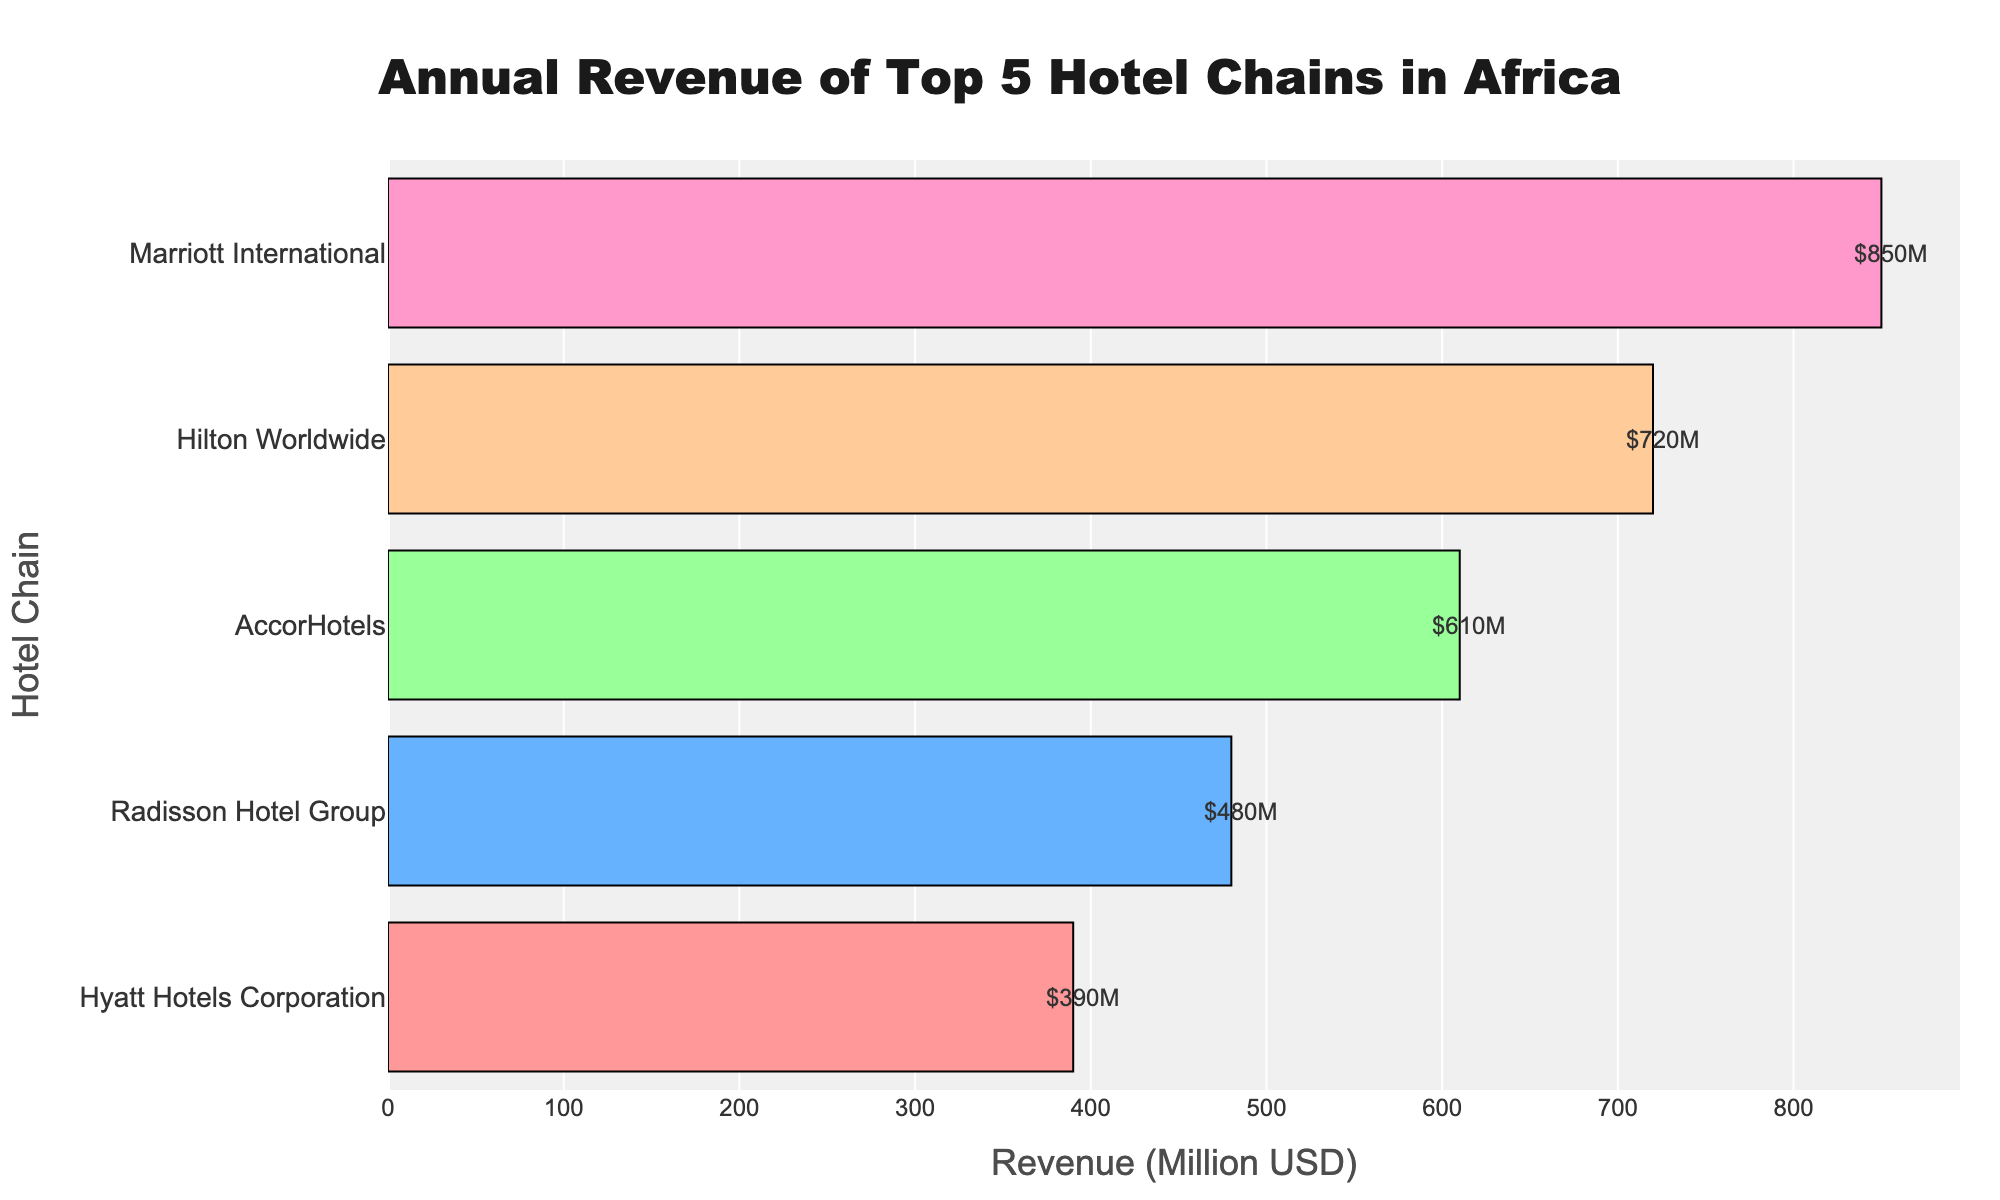What is the title of the figure? The title of the figure is written at the top of the plot. It reads "Annual Revenue of Top 5 Hotel Chains in Africa".
Answer: Annual Revenue of Top 5 Hotel Chains in Africa What is the total revenue of all five hotel chains combined? By summing the revenue values of all five hotel chains: Marriott(850M) + Hilton(720M) + AccorHotels(610M) + Radisson(480M) + Hyatt(390M) = 3050M.
Answer: 3050 Million USD Which hotel chain has the lowest revenue? Look at the bar with the smallest value on the x-axis, which represents Hyatt Hotels Corporation at 390 Million USD.
Answer: Hyatt Hotels Corporation How does the revenue of Marriott International compare to that of Radisson Hotel Group? The revenue of Marriott International is significantly higher than Radisson Hotel Group: Marriott International (850M) vs. Radisson Hotel Group (480M).
Answer: Marriott International has a higher revenue What is the revenue difference between Hilton Worldwide and AccorHotels? To find the difference in revenue, subtract the revenue of AccorHotels from Hilton Worldwide: 720M - 610M = 110M.
Answer: 110 Million USD What is the median revenue among these five hotel chains? To find the median revenue, list the revenues in ascending order: 390M, 480M, 610M, 720M, 850M. The middle value in this ordered list is 610M.
Answer: 610 Million USD Which hotel chain has closest revenue to the median revenue? The median revenue is 610M, and AccorHotels is the chain with that exact revenue.
Answer: AccorHotels What color is the bar representing Marriott International’s revenue? The bar for Marriott International is marked with the first color in the color list, which is a shade of red/pink (#FF9999).
Answer: Red/Pink In what way are the bars annotated? Each bar has a label on the right side showing the revenue in million USD with "M" as the suffix, e.g., "$850M" for Marriott International.
Answer: Revenues in million USD (e.g., $850M) What does the x-axis represent? The x-axis represents the revenue of the hotel chains in million USD.
Answer: Revenue in Million USD 